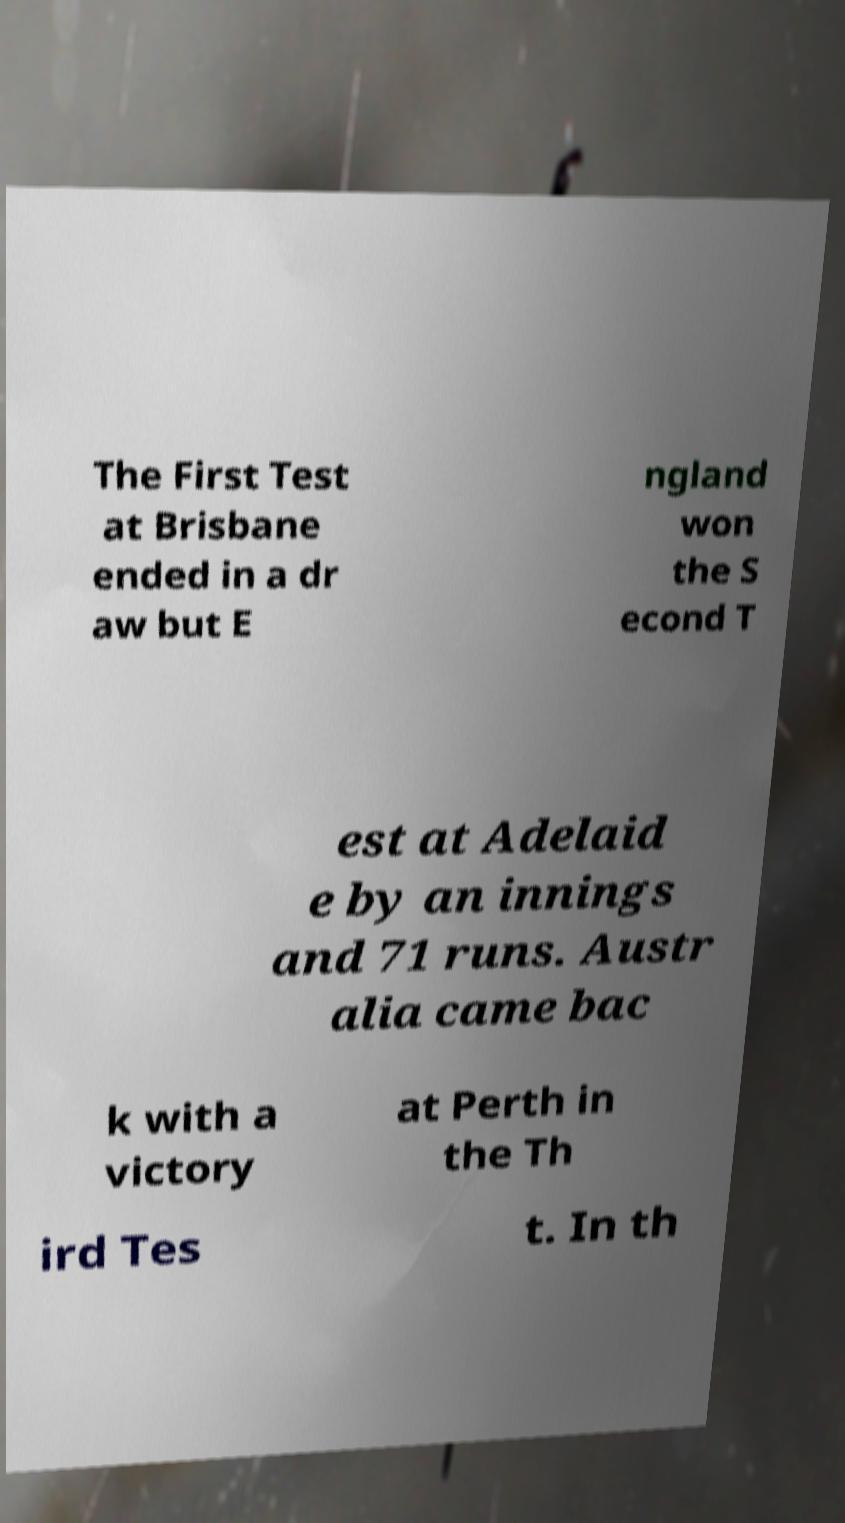For documentation purposes, I need the text within this image transcribed. Could you provide that? The First Test at Brisbane ended in a dr aw but E ngland won the S econd T est at Adelaid e by an innings and 71 runs. Austr alia came bac k with a victory at Perth in the Th ird Tes t. In th 